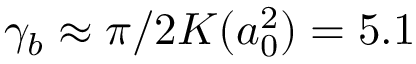<formula> <loc_0><loc_0><loc_500><loc_500>\gamma _ { b } \approx \pi / 2 K ( a _ { 0 } ^ { 2 } ) = 5 . 1</formula> 